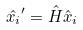Convert formula to latex. <formula><loc_0><loc_0><loc_500><loc_500>\hat { x _ { i } } ^ { \prime } = \hat { H } \hat { x } _ { i }</formula> 